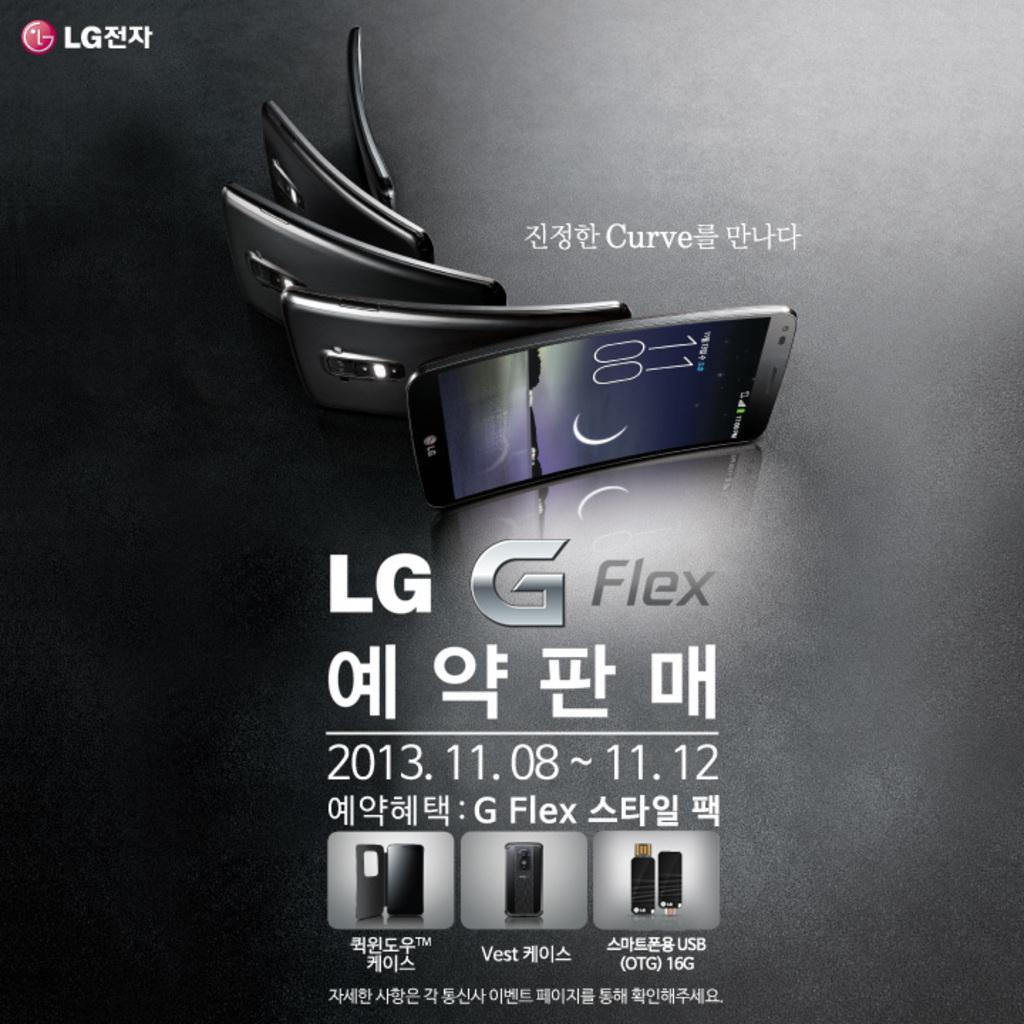<image>
Give a short and clear explanation of the subsequent image. A advertisement for an LG curve G Flex smartphone with the cellphone displayed as it curves. 